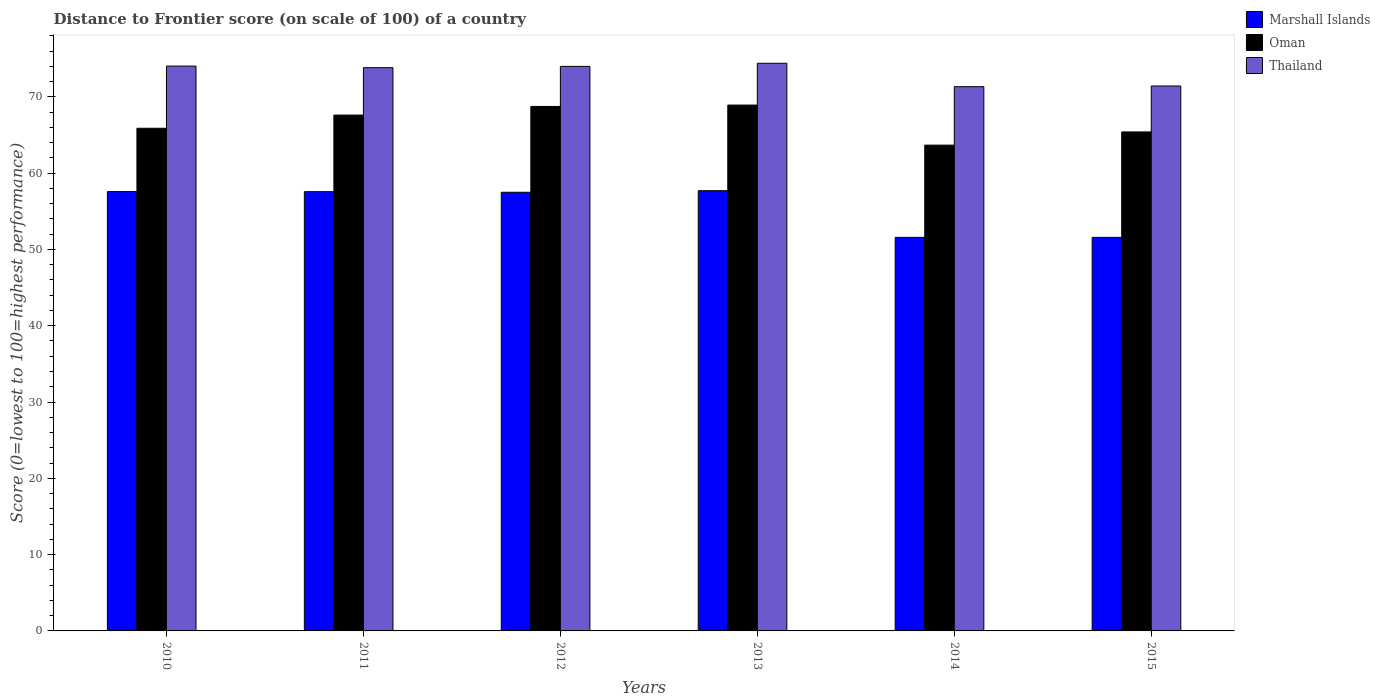How many different coloured bars are there?
Make the answer very short. 3. Are the number of bars on each tick of the X-axis equal?
Your response must be concise. Yes. How many bars are there on the 4th tick from the left?
Offer a terse response. 3. How many bars are there on the 6th tick from the right?
Offer a very short reply. 3. In how many cases, is the number of bars for a given year not equal to the number of legend labels?
Keep it short and to the point. 0. What is the distance to frontier score of in Oman in 2010?
Keep it short and to the point. 65.88. Across all years, what is the maximum distance to frontier score of in Oman?
Make the answer very short. 68.92. Across all years, what is the minimum distance to frontier score of in Marshall Islands?
Give a very brief answer. 51.58. In which year was the distance to frontier score of in Marshall Islands minimum?
Provide a short and direct response. 2014. What is the total distance to frontier score of in Oman in the graph?
Give a very brief answer. 400.22. What is the difference between the distance to frontier score of in Thailand in 2013 and that in 2015?
Provide a succinct answer. 2.98. What is the difference between the distance to frontier score of in Marshall Islands in 2010 and the distance to frontier score of in Thailand in 2013?
Provide a short and direct response. -16.82. What is the average distance to frontier score of in Oman per year?
Give a very brief answer. 66.7. In the year 2013, what is the difference between the distance to frontier score of in Thailand and distance to frontier score of in Marshall Islands?
Keep it short and to the point. 16.7. What is the ratio of the distance to frontier score of in Oman in 2013 to that in 2015?
Provide a succinct answer. 1.05. Is the distance to frontier score of in Marshall Islands in 2012 less than that in 2013?
Make the answer very short. Yes. Is the difference between the distance to frontier score of in Thailand in 2011 and 2013 greater than the difference between the distance to frontier score of in Marshall Islands in 2011 and 2013?
Give a very brief answer. No. What is the difference between the highest and the second highest distance to frontier score of in Oman?
Provide a short and direct response. 0.18. What is the difference between the highest and the lowest distance to frontier score of in Thailand?
Give a very brief answer. 3.07. What does the 2nd bar from the left in 2012 represents?
Make the answer very short. Oman. What does the 1st bar from the right in 2012 represents?
Offer a terse response. Thailand. What is the difference between two consecutive major ticks on the Y-axis?
Your response must be concise. 10. Where does the legend appear in the graph?
Provide a short and direct response. Top right. How many legend labels are there?
Offer a terse response. 3. How are the legend labels stacked?
Offer a terse response. Vertical. What is the title of the graph?
Ensure brevity in your answer.  Distance to Frontier score (on scale of 100) of a country. What is the label or title of the X-axis?
Provide a succinct answer. Years. What is the label or title of the Y-axis?
Give a very brief answer. Score (0=lowest to 100=highest performance). What is the Score (0=lowest to 100=highest performance) of Marshall Islands in 2010?
Your response must be concise. 57.58. What is the Score (0=lowest to 100=highest performance) of Oman in 2010?
Provide a succinct answer. 65.88. What is the Score (0=lowest to 100=highest performance) of Thailand in 2010?
Keep it short and to the point. 74.03. What is the Score (0=lowest to 100=highest performance) in Marshall Islands in 2011?
Provide a succinct answer. 57.57. What is the Score (0=lowest to 100=highest performance) in Oman in 2011?
Your answer should be compact. 67.61. What is the Score (0=lowest to 100=highest performance) in Thailand in 2011?
Offer a terse response. 73.82. What is the Score (0=lowest to 100=highest performance) in Marshall Islands in 2012?
Provide a short and direct response. 57.49. What is the Score (0=lowest to 100=highest performance) in Oman in 2012?
Provide a succinct answer. 68.74. What is the Score (0=lowest to 100=highest performance) in Thailand in 2012?
Provide a succinct answer. 73.99. What is the Score (0=lowest to 100=highest performance) in Marshall Islands in 2013?
Your answer should be very brief. 57.7. What is the Score (0=lowest to 100=highest performance) in Oman in 2013?
Ensure brevity in your answer.  68.92. What is the Score (0=lowest to 100=highest performance) in Thailand in 2013?
Your answer should be compact. 74.4. What is the Score (0=lowest to 100=highest performance) in Marshall Islands in 2014?
Offer a terse response. 51.58. What is the Score (0=lowest to 100=highest performance) in Oman in 2014?
Ensure brevity in your answer.  63.67. What is the Score (0=lowest to 100=highest performance) in Thailand in 2014?
Offer a terse response. 71.33. What is the Score (0=lowest to 100=highest performance) in Marshall Islands in 2015?
Your answer should be very brief. 51.58. What is the Score (0=lowest to 100=highest performance) in Oman in 2015?
Ensure brevity in your answer.  65.4. What is the Score (0=lowest to 100=highest performance) in Thailand in 2015?
Give a very brief answer. 71.42. Across all years, what is the maximum Score (0=lowest to 100=highest performance) of Marshall Islands?
Your response must be concise. 57.7. Across all years, what is the maximum Score (0=lowest to 100=highest performance) in Oman?
Your answer should be compact. 68.92. Across all years, what is the maximum Score (0=lowest to 100=highest performance) in Thailand?
Provide a succinct answer. 74.4. Across all years, what is the minimum Score (0=lowest to 100=highest performance) of Marshall Islands?
Your response must be concise. 51.58. Across all years, what is the minimum Score (0=lowest to 100=highest performance) in Oman?
Keep it short and to the point. 63.67. Across all years, what is the minimum Score (0=lowest to 100=highest performance) in Thailand?
Keep it short and to the point. 71.33. What is the total Score (0=lowest to 100=highest performance) of Marshall Islands in the graph?
Your answer should be very brief. 333.5. What is the total Score (0=lowest to 100=highest performance) of Oman in the graph?
Give a very brief answer. 400.22. What is the total Score (0=lowest to 100=highest performance) of Thailand in the graph?
Provide a succinct answer. 438.99. What is the difference between the Score (0=lowest to 100=highest performance) of Marshall Islands in 2010 and that in 2011?
Your answer should be very brief. 0.01. What is the difference between the Score (0=lowest to 100=highest performance) of Oman in 2010 and that in 2011?
Your answer should be compact. -1.73. What is the difference between the Score (0=lowest to 100=highest performance) in Thailand in 2010 and that in 2011?
Your response must be concise. 0.21. What is the difference between the Score (0=lowest to 100=highest performance) in Marshall Islands in 2010 and that in 2012?
Ensure brevity in your answer.  0.09. What is the difference between the Score (0=lowest to 100=highest performance) of Oman in 2010 and that in 2012?
Keep it short and to the point. -2.86. What is the difference between the Score (0=lowest to 100=highest performance) of Thailand in 2010 and that in 2012?
Offer a very short reply. 0.04. What is the difference between the Score (0=lowest to 100=highest performance) of Marshall Islands in 2010 and that in 2013?
Provide a short and direct response. -0.12. What is the difference between the Score (0=lowest to 100=highest performance) in Oman in 2010 and that in 2013?
Ensure brevity in your answer.  -3.04. What is the difference between the Score (0=lowest to 100=highest performance) in Thailand in 2010 and that in 2013?
Provide a succinct answer. -0.37. What is the difference between the Score (0=lowest to 100=highest performance) of Marshall Islands in 2010 and that in 2014?
Give a very brief answer. 6. What is the difference between the Score (0=lowest to 100=highest performance) of Oman in 2010 and that in 2014?
Provide a short and direct response. 2.21. What is the difference between the Score (0=lowest to 100=highest performance) in Marshall Islands in 2010 and that in 2015?
Your answer should be compact. 6. What is the difference between the Score (0=lowest to 100=highest performance) in Oman in 2010 and that in 2015?
Provide a succinct answer. 0.48. What is the difference between the Score (0=lowest to 100=highest performance) of Thailand in 2010 and that in 2015?
Provide a succinct answer. 2.61. What is the difference between the Score (0=lowest to 100=highest performance) of Marshall Islands in 2011 and that in 2012?
Offer a very short reply. 0.08. What is the difference between the Score (0=lowest to 100=highest performance) of Oman in 2011 and that in 2012?
Offer a very short reply. -1.13. What is the difference between the Score (0=lowest to 100=highest performance) of Thailand in 2011 and that in 2012?
Your answer should be very brief. -0.17. What is the difference between the Score (0=lowest to 100=highest performance) in Marshall Islands in 2011 and that in 2013?
Offer a terse response. -0.13. What is the difference between the Score (0=lowest to 100=highest performance) in Oman in 2011 and that in 2013?
Offer a terse response. -1.31. What is the difference between the Score (0=lowest to 100=highest performance) of Thailand in 2011 and that in 2013?
Provide a succinct answer. -0.58. What is the difference between the Score (0=lowest to 100=highest performance) in Marshall Islands in 2011 and that in 2014?
Give a very brief answer. 5.99. What is the difference between the Score (0=lowest to 100=highest performance) in Oman in 2011 and that in 2014?
Keep it short and to the point. 3.94. What is the difference between the Score (0=lowest to 100=highest performance) of Thailand in 2011 and that in 2014?
Provide a succinct answer. 2.49. What is the difference between the Score (0=lowest to 100=highest performance) in Marshall Islands in 2011 and that in 2015?
Ensure brevity in your answer.  5.99. What is the difference between the Score (0=lowest to 100=highest performance) in Oman in 2011 and that in 2015?
Ensure brevity in your answer.  2.21. What is the difference between the Score (0=lowest to 100=highest performance) of Marshall Islands in 2012 and that in 2013?
Your answer should be compact. -0.21. What is the difference between the Score (0=lowest to 100=highest performance) of Oman in 2012 and that in 2013?
Ensure brevity in your answer.  -0.18. What is the difference between the Score (0=lowest to 100=highest performance) of Thailand in 2012 and that in 2013?
Provide a short and direct response. -0.41. What is the difference between the Score (0=lowest to 100=highest performance) of Marshall Islands in 2012 and that in 2014?
Keep it short and to the point. 5.91. What is the difference between the Score (0=lowest to 100=highest performance) of Oman in 2012 and that in 2014?
Make the answer very short. 5.07. What is the difference between the Score (0=lowest to 100=highest performance) of Thailand in 2012 and that in 2014?
Keep it short and to the point. 2.66. What is the difference between the Score (0=lowest to 100=highest performance) of Marshall Islands in 2012 and that in 2015?
Offer a terse response. 5.91. What is the difference between the Score (0=lowest to 100=highest performance) of Oman in 2012 and that in 2015?
Offer a very short reply. 3.34. What is the difference between the Score (0=lowest to 100=highest performance) of Thailand in 2012 and that in 2015?
Your answer should be very brief. 2.57. What is the difference between the Score (0=lowest to 100=highest performance) in Marshall Islands in 2013 and that in 2014?
Your answer should be very brief. 6.12. What is the difference between the Score (0=lowest to 100=highest performance) of Oman in 2013 and that in 2014?
Provide a succinct answer. 5.25. What is the difference between the Score (0=lowest to 100=highest performance) of Thailand in 2013 and that in 2014?
Make the answer very short. 3.07. What is the difference between the Score (0=lowest to 100=highest performance) of Marshall Islands in 2013 and that in 2015?
Offer a terse response. 6.12. What is the difference between the Score (0=lowest to 100=highest performance) of Oman in 2013 and that in 2015?
Ensure brevity in your answer.  3.52. What is the difference between the Score (0=lowest to 100=highest performance) of Thailand in 2013 and that in 2015?
Your answer should be very brief. 2.98. What is the difference between the Score (0=lowest to 100=highest performance) of Oman in 2014 and that in 2015?
Keep it short and to the point. -1.73. What is the difference between the Score (0=lowest to 100=highest performance) of Thailand in 2014 and that in 2015?
Offer a terse response. -0.09. What is the difference between the Score (0=lowest to 100=highest performance) in Marshall Islands in 2010 and the Score (0=lowest to 100=highest performance) in Oman in 2011?
Make the answer very short. -10.03. What is the difference between the Score (0=lowest to 100=highest performance) in Marshall Islands in 2010 and the Score (0=lowest to 100=highest performance) in Thailand in 2011?
Your answer should be very brief. -16.24. What is the difference between the Score (0=lowest to 100=highest performance) of Oman in 2010 and the Score (0=lowest to 100=highest performance) of Thailand in 2011?
Keep it short and to the point. -7.94. What is the difference between the Score (0=lowest to 100=highest performance) in Marshall Islands in 2010 and the Score (0=lowest to 100=highest performance) in Oman in 2012?
Your answer should be very brief. -11.16. What is the difference between the Score (0=lowest to 100=highest performance) of Marshall Islands in 2010 and the Score (0=lowest to 100=highest performance) of Thailand in 2012?
Your response must be concise. -16.41. What is the difference between the Score (0=lowest to 100=highest performance) in Oman in 2010 and the Score (0=lowest to 100=highest performance) in Thailand in 2012?
Offer a very short reply. -8.11. What is the difference between the Score (0=lowest to 100=highest performance) in Marshall Islands in 2010 and the Score (0=lowest to 100=highest performance) in Oman in 2013?
Your answer should be compact. -11.34. What is the difference between the Score (0=lowest to 100=highest performance) in Marshall Islands in 2010 and the Score (0=lowest to 100=highest performance) in Thailand in 2013?
Give a very brief answer. -16.82. What is the difference between the Score (0=lowest to 100=highest performance) of Oman in 2010 and the Score (0=lowest to 100=highest performance) of Thailand in 2013?
Keep it short and to the point. -8.52. What is the difference between the Score (0=lowest to 100=highest performance) of Marshall Islands in 2010 and the Score (0=lowest to 100=highest performance) of Oman in 2014?
Your response must be concise. -6.09. What is the difference between the Score (0=lowest to 100=highest performance) of Marshall Islands in 2010 and the Score (0=lowest to 100=highest performance) of Thailand in 2014?
Your answer should be compact. -13.75. What is the difference between the Score (0=lowest to 100=highest performance) of Oman in 2010 and the Score (0=lowest to 100=highest performance) of Thailand in 2014?
Your answer should be compact. -5.45. What is the difference between the Score (0=lowest to 100=highest performance) in Marshall Islands in 2010 and the Score (0=lowest to 100=highest performance) in Oman in 2015?
Your answer should be very brief. -7.82. What is the difference between the Score (0=lowest to 100=highest performance) in Marshall Islands in 2010 and the Score (0=lowest to 100=highest performance) in Thailand in 2015?
Give a very brief answer. -13.84. What is the difference between the Score (0=lowest to 100=highest performance) of Oman in 2010 and the Score (0=lowest to 100=highest performance) of Thailand in 2015?
Give a very brief answer. -5.54. What is the difference between the Score (0=lowest to 100=highest performance) of Marshall Islands in 2011 and the Score (0=lowest to 100=highest performance) of Oman in 2012?
Provide a short and direct response. -11.17. What is the difference between the Score (0=lowest to 100=highest performance) in Marshall Islands in 2011 and the Score (0=lowest to 100=highest performance) in Thailand in 2012?
Your answer should be very brief. -16.42. What is the difference between the Score (0=lowest to 100=highest performance) in Oman in 2011 and the Score (0=lowest to 100=highest performance) in Thailand in 2012?
Provide a succinct answer. -6.38. What is the difference between the Score (0=lowest to 100=highest performance) of Marshall Islands in 2011 and the Score (0=lowest to 100=highest performance) of Oman in 2013?
Ensure brevity in your answer.  -11.35. What is the difference between the Score (0=lowest to 100=highest performance) of Marshall Islands in 2011 and the Score (0=lowest to 100=highest performance) of Thailand in 2013?
Give a very brief answer. -16.83. What is the difference between the Score (0=lowest to 100=highest performance) in Oman in 2011 and the Score (0=lowest to 100=highest performance) in Thailand in 2013?
Provide a short and direct response. -6.79. What is the difference between the Score (0=lowest to 100=highest performance) in Marshall Islands in 2011 and the Score (0=lowest to 100=highest performance) in Oman in 2014?
Give a very brief answer. -6.1. What is the difference between the Score (0=lowest to 100=highest performance) of Marshall Islands in 2011 and the Score (0=lowest to 100=highest performance) of Thailand in 2014?
Offer a very short reply. -13.76. What is the difference between the Score (0=lowest to 100=highest performance) of Oman in 2011 and the Score (0=lowest to 100=highest performance) of Thailand in 2014?
Your answer should be compact. -3.72. What is the difference between the Score (0=lowest to 100=highest performance) in Marshall Islands in 2011 and the Score (0=lowest to 100=highest performance) in Oman in 2015?
Your response must be concise. -7.83. What is the difference between the Score (0=lowest to 100=highest performance) in Marshall Islands in 2011 and the Score (0=lowest to 100=highest performance) in Thailand in 2015?
Keep it short and to the point. -13.85. What is the difference between the Score (0=lowest to 100=highest performance) in Oman in 2011 and the Score (0=lowest to 100=highest performance) in Thailand in 2015?
Offer a very short reply. -3.81. What is the difference between the Score (0=lowest to 100=highest performance) in Marshall Islands in 2012 and the Score (0=lowest to 100=highest performance) in Oman in 2013?
Provide a succinct answer. -11.43. What is the difference between the Score (0=lowest to 100=highest performance) of Marshall Islands in 2012 and the Score (0=lowest to 100=highest performance) of Thailand in 2013?
Your response must be concise. -16.91. What is the difference between the Score (0=lowest to 100=highest performance) in Oman in 2012 and the Score (0=lowest to 100=highest performance) in Thailand in 2013?
Keep it short and to the point. -5.66. What is the difference between the Score (0=lowest to 100=highest performance) of Marshall Islands in 2012 and the Score (0=lowest to 100=highest performance) of Oman in 2014?
Offer a terse response. -6.18. What is the difference between the Score (0=lowest to 100=highest performance) in Marshall Islands in 2012 and the Score (0=lowest to 100=highest performance) in Thailand in 2014?
Offer a very short reply. -13.84. What is the difference between the Score (0=lowest to 100=highest performance) in Oman in 2012 and the Score (0=lowest to 100=highest performance) in Thailand in 2014?
Ensure brevity in your answer.  -2.59. What is the difference between the Score (0=lowest to 100=highest performance) in Marshall Islands in 2012 and the Score (0=lowest to 100=highest performance) in Oman in 2015?
Your answer should be compact. -7.91. What is the difference between the Score (0=lowest to 100=highest performance) of Marshall Islands in 2012 and the Score (0=lowest to 100=highest performance) of Thailand in 2015?
Ensure brevity in your answer.  -13.93. What is the difference between the Score (0=lowest to 100=highest performance) in Oman in 2012 and the Score (0=lowest to 100=highest performance) in Thailand in 2015?
Give a very brief answer. -2.68. What is the difference between the Score (0=lowest to 100=highest performance) of Marshall Islands in 2013 and the Score (0=lowest to 100=highest performance) of Oman in 2014?
Give a very brief answer. -5.97. What is the difference between the Score (0=lowest to 100=highest performance) of Marshall Islands in 2013 and the Score (0=lowest to 100=highest performance) of Thailand in 2014?
Your answer should be compact. -13.63. What is the difference between the Score (0=lowest to 100=highest performance) of Oman in 2013 and the Score (0=lowest to 100=highest performance) of Thailand in 2014?
Offer a terse response. -2.41. What is the difference between the Score (0=lowest to 100=highest performance) in Marshall Islands in 2013 and the Score (0=lowest to 100=highest performance) in Thailand in 2015?
Give a very brief answer. -13.72. What is the difference between the Score (0=lowest to 100=highest performance) of Marshall Islands in 2014 and the Score (0=lowest to 100=highest performance) of Oman in 2015?
Offer a very short reply. -13.82. What is the difference between the Score (0=lowest to 100=highest performance) of Marshall Islands in 2014 and the Score (0=lowest to 100=highest performance) of Thailand in 2015?
Make the answer very short. -19.84. What is the difference between the Score (0=lowest to 100=highest performance) of Oman in 2014 and the Score (0=lowest to 100=highest performance) of Thailand in 2015?
Give a very brief answer. -7.75. What is the average Score (0=lowest to 100=highest performance) in Marshall Islands per year?
Provide a short and direct response. 55.58. What is the average Score (0=lowest to 100=highest performance) in Oman per year?
Your answer should be compact. 66.7. What is the average Score (0=lowest to 100=highest performance) of Thailand per year?
Make the answer very short. 73.17. In the year 2010, what is the difference between the Score (0=lowest to 100=highest performance) of Marshall Islands and Score (0=lowest to 100=highest performance) of Thailand?
Provide a short and direct response. -16.45. In the year 2010, what is the difference between the Score (0=lowest to 100=highest performance) of Oman and Score (0=lowest to 100=highest performance) of Thailand?
Keep it short and to the point. -8.15. In the year 2011, what is the difference between the Score (0=lowest to 100=highest performance) in Marshall Islands and Score (0=lowest to 100=highest performance) in Oman?
Give a very brief answer. -10.04. In the year 2011, what is the difference between the Score (0=lowest to 100=highest performance) in Marshall Islands and Score (0=lowest to 100=highest performance) in Thailand?
Ensure brevity in your answer.  -16.25. In the year 2011, what is the difference between the Score (0=lowest to 100=highest performance) of Oman and Score (0=lowest to 100=highest performance) of Thailand?
Your response must be concise. -6.21. In the year 2012, what is the difference between the Score (0=lowest to 100=highest performance) of Marshall Islands and Score (0=lowest to 100=highest performance) of Oman?
Keep it short and to the point. -11.25. In the year 2012, what is the difference between the Score (0=lowest to 100=highest performance) in Marshall Islands and Score (0=lowest to 100=highest performance) in Thailand?
Offer a very short reply. -16.5. In the year 2012, what is the difference between the Score (0=lowest to 100=highest performance) of Oman and Score (0=lowest to 100=highest performance) of Thailand?
Make the answer very short. -5.25. In the year 2013, what is the difference between the Score (0=lowest to 100=highest performance) of Marshall Islands and Score (0=lowest to 100=highest performance) of Oman?
Provide a succinct answer. -11.22. In the year 2013, what is the difference between the Score (0=lowest to 100=highest performance) in Marshall Islands and Score (0=lowest to 100=highest performance) in Thailand?
Your answer should be compact. -16.7. In the year 2013, what is the difference between the Score (0=lowest to 100=highest performance) of Oman and Score (0=lowest to 100=highest performance) of Thailand?
Give a very brief answer. -5.48. In the year 2014, what is the difference between the Score (0=lowest to 100=highest performance) of Marshall Islands and Score (0=lowest to 100=highest performance) of Oman?
Provide a succinct answer. -12.09. In the year 2014, what is the difference between the Score (0=lowest to 100=highest performance) of Marshall Islands and Score (0=lowest to 100=highest performance) of Thailand?
Your response must be concise. -19.75. In the year 2014, what is the difference between the Score (0=lowest to 100=highest performance) in Oman and Score (0=lowest to 100=highest performance) in Thailand?
Provide a succinct answer. -7.66. In the year 2015, what is the difference between the Score (0=lowest to 100=highest performance) of Marshall Islands and Score (0=lowest to 100=highest performance) of Oman?
Ensure brevity in your answer.  -13.82. In the year 2015, what is the difference between the Score (0=lowest to 100=highest performance) of Marshall Islands and Score (0=lowest to 100=highest performance) of Thailand?
Give a very brief answer. -19.84. In the year 2015, what is the difference between the Score (0=lowest to 100=highest performance) in Oman and Score (0=lowest to 100=highest performance) in Thailand?
Keep it short and to the point. -6.02. What is the ratio of the Score (0=lowest to 100=highest performance) of Oman in 2010 to that in 2011?
Keep it short and to the point. 0.97. What is the ratio of the Score (0=lowest to 100=highest performance) of Thailand in 2010 to that in 2011?
Ensure brevity in your answer.  1. What is the ratio of the Score (0=lowest to 100=highest performance) in Oman in 2010 to that in 2012?
Give a very brief answer. 0.96. What is the ratio of the Score (0=lowest to 100=highest performance) of Marshall Islands in 2010 to that in 2013?
Keep it short and to the point. 1. What is the ratio of the Score (0=lowest to 100=highest performance) of Oman in 2010 to that in 2013?
Provide a succinct answer. 0.96. What is the ratio of the Score (0=lowest to 100=highest performance) in Marshall Islands in 2010 to that in 2014?
Give a very brief answer. 1.12. What is the ratio of the Score (0=lowest to 100=highest performance) in Oman in 2010 to that in 2014?
Make the answer very short. 1.03. What is the ratio of the Score (0=lowest to 100=highest performance) of Thailand in 2010 to that in 2014?
Offer a very short reply. 1.04. What is the ratio of the Score (0=lowest to 100=highest performance) in Marshall Islands in 2010 to that in 2015?
Provide a succinct answer. 1.12. What is the ratio of the Score (0=lowest to 100=highest performance) of Oman in 2010 to that in 2015?
Give a very brief answer. 1.01. What is the ratio of the Score (0=lowest to 100=highest performance) in Thailand in 2010 to that in 2015?
Give a very brief answer. 1.04. What is the ratio of the Score (0=lowest to 100=highest performance) of Oman in 2011 to that in 2012?
Offer a very short reply. 0.98. What is the ratio of the Score (0=lowest to 100=highest performance) in Thailand in 2011 to that in 2012?
Your answer should be very brief. 1. What is the ratio of the Score (0=lowest to 100=highest performance) of Marshall Islands in 2011 to that in 2013?
Your response must be concise. 1. What is the ratio of the Score (0=lowest to 100=highest performance) of Marshall Islands in 2011 to that in 2014?
Your answer should be compact. 1.12. What is the ratio of the Score (0=lowest to 100=highest performance) in Oman in 2011 to that in 2014?
Offer a terse response. 1.06. What is the ratio of the Score (0=lowest to 100=highest performance) of Thailand in 2011 to that in 2014?
Offer a very short reply. 1.03. What is the ratio of the Score (0=lowest to 100=highest performance) of Marshall Islands in 2011 to that in 2015?
Your answer should be very brief. 1.12. What is the ratio of the Score (0=lowest to 100=highest performance) of Oman in 2011 to that in 2015?
Offer a terse response. 1.03. What is the ratio of the Score (0=lowest to 100=highest performance) in Thailand in 2011 to that in 2015?
Your response must be concise. 1.03. What is the ratio of the Score (0=lowest to 100=highest performance) of Thailand in 2012 to that in 2013?
Offer a very short reply. 0.99. What is the ratio of the Score (0=lowest to 100=highest performance) in Marshall Islands in 2012 to that in 2014?
Give a very brief answer. 1.11. What is the ratio of the Score (0=lowest to 100=highest performance) of Oman in 2012 to that in 2014?
Provide a succinct answer. 1.08. What is the ratio of the Score (0=lowest to 100=highest performance) in Thailand in 2012 to that in 2014?
Give a very brief answer. 1.04. What is the ratio of the Score (0=lowest to 100=highest performance) in Marshall Islands in 2012 to that in 2015?
Ensure brevity in your answer.  1.11. What is the ratio of the Score (0=lowest to 100=highest performance) in Oman in 2012 to that in 2015?
Give a very brief answer. 1.05. What is the ratio of the Score (0=lowest to 100=highest performance) of Thailand in 2012 to that in 2015?
Your answer should be very brief. 1.04. What is the ratio of the Score (0=lowest to 100=highest performance) of Marshall Islands in 2013 to that in 2014?
Offer a terse response. 1.12. What is the ratio of the Score (0=lowest to 100=highest performance) of Oman in 2013 to that in 2014?
Offer a very short reply. 1.08. What is the ratio of the Score (0=lowest to 100=highest performance) in Thailand in 2013 to that in 2014?
Ensure brevity in your answer.  1.04. What is the ratio of the Score (0=lowest to 100=highest performance) of Marshall Islands in 2013 to that in 2015?
Provide a succinct answer. 1.12. What is the ratio of the Score (0=lowest to 100=highest performance) of Oman in 2013 to that in 2015?
Provide a succinct answer. 1.05. What is the ratio of the Score (0=lowest to 100=highest performance) in Thailand in 2013 to that in 2015?
Give a very brief answer. 1.04. What is the ratio of the Score (0=lowest to 100=highest performance) in Marshall Islands in 2014 to that in 2015?
Your answer should be compact. 1. What is the ratio of the Score (0=lowest to 100=highest performance) in Oman in 2014 to that in 2015?
Your response must be concise. 0.97. What is the difference between the highest and the second highest Score (0=lowest to 100=highest performance) in Marshall Islands?
Offer a very short reply. 0.12. What is the difference between the highest and the second highest Score (0=lowest to 100=highest performance) of Oman?
Provide a succinct answer. 0.18. What is the difference between the highest and the second highest Score (0=lowest to 100=highest performance) in Thailand?
Your answer should be very brief. 0.37. What is the difference between the highest and the lowest Score (0=lowest to 100=highest performance) of Marshall Islands?
Provide a succinct answer. 6.12. What is the difference between the highest and the lowest Score (0=lowest to 100=highest performance) in Oman?
Provide a short and direct response. 5.25. What is the difference between the highest and the lowest Score (0=lowest to 100=highest performance) in Thailand?
Give a very brief answer. 3.07. 